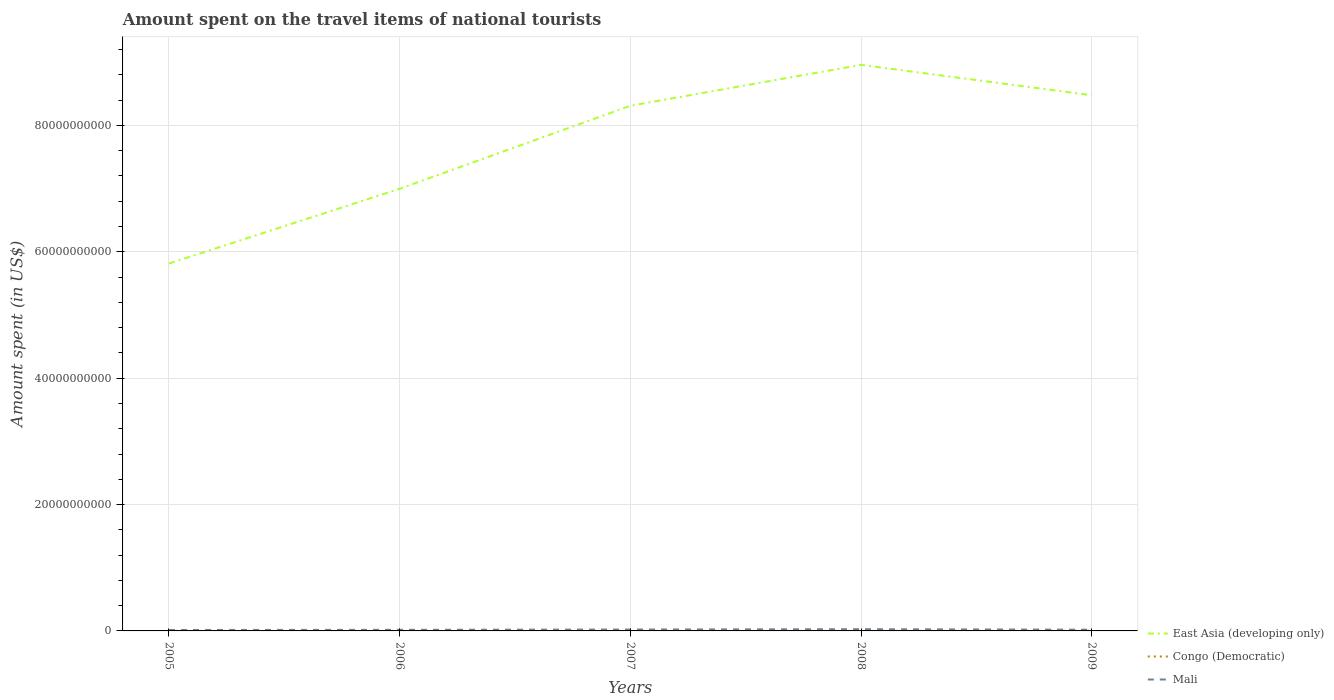In which year was the amount spent on the travel items of national tourists in Mali maximum?
Ensure brevity in your answer.  2005. What is the total amount spent on the travel items of national tourists in Mali in the graph?
Make the answer very short. 2.90e+07. What is the difference between the highest and the second highest amount spent on the travel items of national tourists in Mali?
Your response must be concise. 1.27e+08. What is the difference between the highest and the lowest amount spent on the travel items of national tourists in Mali?
Give a very brief answer. 2. Is the amount spent on the travel items of national tourists in Congo (Democratic) strictly greater than the amount spent on the travel items of national tourists in East Asia (developing only) over the years?
Offer a very short reply. Yes. How many years are there in the graph?
Give a very brief answer. 5. What is the difference between two consecutive major ticks on the Y-axis?
Make the answer very short. 2.00e+1. Does the graph contain grids?
Offer a terse response. Yes. Where does the legend appear in the graph?
Your response must be concise. Bottom right. How many legend labels are there?
Offer a very short reply. 3. What is the title of the graph?
Your answer should be compact. Amount spent on the travel items of national tourists. Does "San Marino" appear as one of the legend labels in the graph?
Your answer should be very brief. No. What is the label or title of the Y-axis?
Offer a very short reply. Amount spent (in US$). What is the Amount spent (in US$) in East Asia (developing only) in 2005?
Provide a succinct answer. 5.81e+1. What is the Amount spent (in US$) of Congo (Democratic) in 2005?
Provide a short and direct response. 3.20e+06. What is the Amount spent (in US$) in Mali in 2005?
Keep it short and to the point. 1.48e+08. What is the Amount spent (in US$) in East Asia (developing only) in 2006?
Provide a short and direct response. 7.00e+1. What is the Amount spent (in US$) in Congo (Democratic) in 2006?
Your answer should be compact. 3.10e+06. What is the Amount spent (in US$) in Mali in 2006?
Offer a terse response. 1.75e+08. What is the Amount spent (in US$) in East Asia (developing only) in 2007?
Make the answer very short. 8.31e+1. What is the Amount spent (in US$) of Mali in 2007?
Ensure brevity in your answer.  2.21e+08. What is the Amount spent (in US$) in East Asia (developing only) in 2008?
Provide a succinct answer. 8.96e+1. What is the Amount spent (in US$) in Mali in 2008?
Provide a short and direct response. 2.75e+08. What is the Amount spent (in US$) in East Asia (developing only) in 2009?
Your answer should be compact. 8.48e+1. What is the Amount spent (in US$) of Congo (Democratic) in 2009?
Ensure brevity in your answer.  2.40e+07. What is the Amount spent (in US$) in Mali in 2009?
Your answer should be very brief. 1.92e+08. Across all years, what is the maximum Amount spent (in US$) in East Asia (developing only)?
Offer a terse response. 8.96e+1. Across all years, what is the maximum Amount spent (in US$) in Congo (Democratic)?
Offer a terse response. 2.40e+07. Across all years, what is the maximum Amount spent (in US$) of Mali?
Keep it short and to the point. 2.75e+08. Across all years, what is the minimum Amount spent (in US$) of East Asia (developing only)?
Keep it short and to the point. 5.81e+1. Across all years, what is the minimum Amount spent (in US$) of Mali?
Ensure brevity in your answer.  1.48e+08. What is the total Amount spent (in US$) in East Asia (developing only) in the graph?
Give a very brief answer. 3.86e+11. What is the total Amount spent (in US$) in Congo (Democratic) in the graph?
Your answer should be compact. 3.17e+07. What is the total Amount spent (in US$) in Mali in the graph?
Your answer should be compact. 1.01e+09. What is the difference between the Amount spent (in US$) in East Asia (developing only) in 2005 and that in 2006?
Ensure brevity in your answer.  -1.18e+1. What is the difference between the Amount spent (in US$) of Congo (Democratic) in 2005 and that in 2006?
Make the answer very short. 1.00e+05. What is the difference between the Amount spent (in US$) of Mali in 2005 and that in 2006?
Offer a terse response. -2.70e+07. What is the difference between the Amount spent (in US$) of East Asia (developing only) in 2005 and that in 2007?
Offer a terse response. -2.50e+1. What is the difference between the Amount spent (in US$) in Congo (Democratic) in 2005 and that in 2007?
Make the answer very short. 2.50e+06. What is the difference between the Amount spent (in US$) of Mali in 2005 and that in 2007?
Provide a succinct answer. -7.30e+07. What is the difference between the Amount spent (in US$) in East Asia (developing only) in 2005 and that in 2008?
Keep it short and to the point. -3.14e+1. What is the difference between the Amount spent (in US$) of Congo (Democratic) in 2005 and that in 2008?
Your answer should be very brief. 2.50e+06. What is the difference between the Amount spent (in US$) in Mali in 2005 and that in 2008?
Ensure brevity in your answer.  -1.27e+08. What is the difference between the Amount spent (in US$) of East Asia (developing only) in 2005 and that in 2009?
Provide a short and direct response. -2.66e+1. What is the difference between the Amount spent (in US$) in Congo (Democratic) in 2005 and that in 2009?
Keep it short and to the point. -2.08e+07. What is the difference between the Amount spent (in US$) in Mali in 2005 and that in 2009?
Your response must be concise. -4.40e+07. What is the difference between the Amount spent (in US$) of East Asia (developing only) in 2006 and that in 2007?
Your response must be concise. -1.31e+1. What is the difference between the Amount spent (in US$) in Congo (Democratic) in 2006 and that in 2007?
Ensure brevity in your answer.  2.40e+06. What is the difference between the Amount spent (in US$) in Mali in 2006 and that in 2007?
Your answer should be compact. -4.60e+07. What is the difference between the Amount spent (in US$) of East Asia (developing only) in 2006 and that in 2008?
Keep it short and to the point. -1.96e+1. What is the difference between the Amount spent (in US$) of Congo (Democratic) in 2006 and that in 2008?
Your answer should be very brief. 2.40e+06. What is the difference between the Amount spent (in US$) in Mali in 2006 and that in 2008?
Keep it short and to the point. -1.00e+08. What is the difference between the Amount spent (in US$) of East Asia (developing only) in 2006 and that in 2009?
Offer a very short reply. -1.48e+1. What is the difference between the Amount spent (in US$) of Congo (Democratic) in 2006 and that in 2009?
Offer a very short reply. -2.09e+07. What is the difference between the Amount spent (in US$) in Mali in 2006 and that in 2009?
Provide a short and direct response. -1.70e+07. What is the difference between the Amount spent (in US$) of East Asia (developing only) in 2007 and that in 2008?
Ensure brevity in your answer.  -6.47e+09. What is the difference between the Amount spent (in US$) of Mali in 2007 and that in 2008?
Your answer should be compact. -5.40e+07. What is the difference between the Amount spent (in US$) in East Asia (developing only) in 2007 and that in 2009?
Provide a short and direct response. -1.67e+09. What is the difference between the Amount spent (in US$) in Congo (Democratic) in 2007 and that in 2009?
Your answer should be compact. -2.33e+07. What is the difference between the Amount spent (in US$) of Mali in 2007 and that in 2009?
Your response must be concise. 2.90e+07. What is the difference between the Amount spent (in US$) in East Asia (developing only) in 2008 and that in 2009?
Provide a short and direct response. 4.81e+09. What is the difference between the Amount spent (in US$) of Congo (Democratic) in 2008 and that in 2009?
Provide a short and direct response. -2.33e+07. What is the difference between the Amount spent (in US$) of Mali in 2008 and that in 2009?
Your answer should be very brief. 8.30e+07. What is the difference between the Amount spent (in US$) in East Asia (developing only) in 2005 and the Amount spent (in US$) in Congo (Democratic) in 2006?
Your response must be concise. 5.81e+1. What is the difference between the Amount spent (in US$) in East Asia (developing only) in 2005 and the Amount spent (in US$) in Mali in 2006?
Offer a terse response. 5.80e+1. What is the difference between the Amount spent (in US$) in Congo (Democratic) in 2005 and the Amount spent (in US$) in Mali in 2006?
Provide a short and direct response. -1.72e+08. What is the difference between the Amount spent (in US$) in East Asia (developing only) in 2005 and the Amount spent (in US$) in Congo (Democratic) in 2007?
Provide a short and direct response. 5.81e+1. What is the difference between the Amount spent (in US$) of East Asia (developing only) in 2005 and the Amount spent (in US$) of Mali in 2007?
Give a very brief answer. 5.79e+1. What is the difference between the Amount spent (in US$) of Congo (Democratic) in 2005 and the Amount spent (in US$) of Mali in 2007?
Offer a very short reply. -2.18e+08. What is the difference between the Amount spent (in US$) in East Asia (developing only) in 2005 and the Amount spent (in US$) in Congo (Democratic) in 2008?
Ensure brevity in your answer.  5.81e+1. What is the difference between the Amount spent (in US$) in East Asia (developing only) in 2005 and the Amount spent (in US$) in Mali in 2008?
Provide a short and direct response. 5.79e+1. What is the difference between the Amount spent (in US$) of Congo (Democratic) in 2005 and the Amount spent (in US$) of Mali in 2008?
Your answer should be compact. -2.72e+08. What is the difference between the Amount spent (in US$) in East Asia (developing only) in 2005 and the Amount spent (in US$) in Congo (Democratic) in 2009?
Offer a very short reply. 5.81e+1. What is the difference between the Amount spent (in US$) of East Asia (developing only) in 2005 and the Amount spent (in US$) of Mali in 2009?
Ensure brevity in your answer.  5.80e+1. What is the difference between the Amount spent (in US$) of Congo (Democratic) in 2005 and the Amount spent (in US$) of Mali in 2009?
Provide a succinct answer. -1.89e+08. What is the difference between the Amount spent (in US$) in East Asia (developing only) in 2006 and the Amount spent (in US$) in Congo (Democratic) in 2007?
Provide a succinct answer. 7.00e+1. What is the difference between the Amount spent (in US$) in East Asia (developing only) in 2006 and the Amount spent (in US$) in Mali in 2007?
Offer a terse response. 6.98e+1. What is the difference between the Amount spent (in US$) of Congo (Democratic) in 2006 and the Amount spent (in US$) of Mali in 2007?
Your answer should be very brief. -2.18e+08. What is the difference between the Amount spent (in US$) in East Asia (developing only) in 2006 and the Amount spent (in US$) in Congo (Democratic) in 2008?
Ensure brevity in your answer.  7.00e+1. What is the difference between the Amount spent (in US$) of East Asia (developing only) in 2006 and the Amount spent (in US$) of Mali in 2008?
Keep it short and to the point. 6.97e+1. What is the difference between the Amount spent (in US$) in Congo (Democratic) in 2006 and the Amount spent (in US$) in Mali in 2008?
Your answer should be compact. -2.72e+08. What is the difference between the Amount spent (in US$) of East Asia (developing only) in 2006 and the Amount spent (in US$) of Congo (Democratic) in 2009?
Provide a short and direct response. 7.00e+1. What is the difference between the Amount spent (in US$) in East Asia (developing only) in 2006 and the Amount spent (in US$) in Mali in 2009?
Your answer should be very brief. 6.98e+1. What is the difference between the Amount spent (in US$) in Congo (Democratic) in 2006 and the Amount spent (in US$) in Mali in 2009?
Your response must be concise. -1.89e+08. What is the difference between the Amount spent (in US$) of East Asia (developing only) in 2007 and the Amount spent (in US$) of Congo (Democratic) in 2008?
Offer a terse response. 8.31e+1. What is the difference between the Amount spent (in US$) in East Asia (developing only) in 2007 and the Amount spent (in US$) in Mali in 2008?
Ensure brevity in your answer.  8.28e+1. What is the difference between the Amount spent (in US$) in Congo (Democratic) in 2007 and the Amount spent (in US$) in Mali in 2008?
Offer a terse response. -2.74e+08. What is the difference between the Amount spent (in US$) in East Asia (developing only) in 2007 and the Amount spent (in US$) in Congo (Democratic) in 2009?
Offer a terse response. 8.31e+1. What is the difference between the Amount spent (in US$) in East Asia (developing only) in 2007 and the Amount spent (in US$) in Mali in 2009?
Provide a succinct answer. 8.29e+1. What is the difference between the Amount spent (in US$) in Congo (Democratic) in 2007 and the Amount spent (in US$) in Mali in 2009?
Offer a terse response. -1.91e+08. What is the difference between the Amount spent (in US$) in East Asia (developing only) in 2008 and the Amount spent (in US$) in Congo (Democratic) in 2009?
Ensure brevity in your answer.  8.96e+1. What is the difference between the Amount spent (in US$) of East Asia (developing only) in 2008 and the Amount spent (in US$) of Mali in 2009?
Your answer should be compact. 8.94e+1. What is the difference between the Amount spent (in US$) in Congo (Democratic) in 2008 and the Amount spent (in US$) in Mali in 2009?
Offer a terse response. -1.91e+08. What is the average Amount spent (in US$) in East Asia (developing only) per year?
Offer a very short reply. 7.71e+1. What is the average Amount spent (in US$) of Congo (Democratic) per year?
Ensure brevity in your answer.  6.34e+06. What is the average Amount spent (in US$) in Mali per year?
Make the answer very short. 2.02e+08. In the year 2005, what is the difference between the Amount spent (in US$) of East Asia (developing only) and Amount spent (in US$) of Congo (Democratic)?
Your answer should be compact. 5.81e+1. In the year 2005, what is the difference between the Amount spent (in US$) of East Asia (developing only) and Amount spent (in US$) of Mali?
Your response must be concise. 5.80e+1. In the year 2005, what is the difference between the Amount spent (in US$) in Congo (Democratic) and Amount spent (in US$) in Mali?
Provide a succinct answer. -1.45e+08. In the year 2006, what is the difference between the Amount spent (in US$) of East Asia (developing only) and Amount spent (in US$) of Congo (Democratic)?
Make the answer very short. 7.00e+1. In the year 2006, what is the difference between the Amount spent (in US$) of East Asia (developing only) and Amount spent (in US$) of Mali?
Your answer should be very brief. 6.98e+1. In the year 2006, what is the difference between the Amount spent (in US$) in Congo (Democratic) and Amount spent (in US$) in Mali?
Provide a short and direct response. -1.72e+08. In the year 2007, what is the difference between the Amount spent (in US$) in East Asia (developing only) and Amount spent (in US$) in Congo (Democratic)?
Offer a very short reply. 8.31e+1. In the year 2007, what is the difference between the Amount spent (in US$) of East Asia (developing only) and Amount spent (in US$) of Mali?
Give a very brief answer. 8.29e+1. In the year 2007, what is the difference between the Amount spent (in US$) of Congo (Democratic) and Amount spent (in US$) of Mali?
Keep it short and to the point. -2.20e+08. In the year 2008, what is the difference between the Amount spent (in US$) of East Asia (developing only) and Amount spent (in US$) of Congo (Democratic)?
Your answer should be compact. 8.96e+1. In the year 2008, what is the difference between the Amount spent (in US$) in East Asia (developing only) and Amount spent (in US$) in Mali?
Keep it short and to the point. 8.93e+1. In the year 2008, what is the difference between the Amount spent (in US$) of Congo (Democratic) and Amount spent (in US$) of Mali?
Offer a very short reply. -2.74e+08. In the year 2009, what is the difference between the Amount spent (in US$) of East Asia (developing only) and Amount spent (in US$) of Congo (Democratic)?
Make the answer very short. 8.48e+1. In the year 2009, what is the difference between the Amount spent (in US$) of East Asia (developing only) and Amount spent (in US$) of Mali?
Your answer should be very brief. 8.46e+1. In the year 2009, what is the difference between the Amount spent (in US$) of Congo (Democratic) and Amount spent (in US$) of Mali?
Your answer should be very brief. -1.68e+08. What is the ratio of the Amount spent (in US$) of East Asia (developing only) in 2005 to that in 2006?
Offer a terse response. 0.83. What is the ratio of the Amount spent (in US$) in Congo (Democratic) in 2005 to that in 2006?
Provide a short and direct response. 1.03. What is the ratio of the Amount spent (in US$) in Mali in 2005 to that in 2006?
Ensure brevity in your answer.  0.85. What is the ratio of the Amount spent (in US$) in East Asia (developing only) in 2005 to that in 2007?
Offer a terse response. 0.7. What is the ratio of the Amount spent (in US$) of Congo (Democratic) in 2005 to that in 2007?
Provide a succinct answer. 4.57. What is the ratio of the Amount spent (in US$) in Mali in 2005 to that in 2007?
Ensure brevity in your answer.  0.67. What is the ratio of the Amount spent (in US$) of East Asia (developing only) in 2005 to that in 2008?
Offer a very short reply. 0.65. What is the ratio of the Amount spent (in US$) in Congo (Democratic) in 2005 to that in 2008?
Your response must be concise. 4.57. What is the ratio of the Amount spent (in US$) of Mali in 2005 to that in 2008?
Give a very brief answer. 0.54. What is the ratio of the Amount spent (in US$) of East Asia (developing only) in 2005 to that in 2009?
Provide a succinct answer. 0.69. What is the ratio of the Amount spent (in US$) of Congo (Democratic) in 2005 to that in 2009?
Ensure brevity in your answer.  0.13. What is the ratio of the Amount spent (in US$) in Mali in 2005 to that in 2009?
Offer a terse response. 0.77. What is the ratio of the Amount spent (in US$) of East Asia (developing only) in 2006 to that in 2007?
Give a very brief answer. 0.84. What is the ratio of the Amount spent (in US$) of Congo (Democratic) in 2006 to that in 2007?
Offer a very short reply. 4.43. What is the ratio of the Amount spent (in US$) in Mali in 2006 to that in 2007?
Keep it short and to the point. 0.79. What is the ratio of the Amount spent (in US$) of East Asia (developing only) in 2006 to that in 2008?
Make the answer very short. 0.78. What is the ratio of the Amount spent (in US$) of Congo (Democratic) in 2006 to that in 2008?
Offer a very short reply. 4.43. What is the ratio of the Amount spent (in US$) of Mali in 2006 to that in 2008?
Give a very brief answer. 0.64. What is the ratio of the Amount spent (in US$) in East Asia (developing only) in 2006 to that in 2009?
Keep it short and to the point. 0.83. What is the ratio of the Amount spent (in US$) in Congo (Democratic) in 2006 to that in 2009?
Give a very brief answer. 0.13. What is the ratio of the Amount spent (in US$) of Mali in 2006 to that in 2009?
Provide a succinct answer. 0.91. What is the ratio of the Amount spent (in US$) of East Asia (developing only) in 2007 to that in 2008?
Provide a succinct answer. 0.93. What is the ratio of the Amount spent (in US$) in Congo (Democratic) in 2007 to that in 2008?
Provide a succinct answer. 1. What is the ratio of the Amount spent (in US$) of Mali in 2007 to that in 2008?
Give a very brief answer. 0.8. What is the ratio of the Amount spent (in US$) of East Asia (developing only) in 2007 to that in 2009?
Offer a very short reply. 0.98. What is the ratio of the Amount spent (in US$) of Congo (Democratic) in 2007 to that in 2009?
Your response must be concise. 0.03. What is the ratio of the Amount spent (in US$) in Mali in 2007 to that in 2009?
Your response must be concise. 1.15. What is the ratio of the Amount spent (in US$) in East Asia (developing only) in 2008 to that in 2009?
Offer a very short reply. 1.06. What is the ratio of the Amount spent (in US$) of Congo (Democratic) in 2008 to that in 2009?
Ensure brevity in your answer.  0.03. What is the ratio of the Amount spent (in US$) of Mali in 2008 to that in 2009?
Offer a very short reply. 1.43. What is the difference between the highest and the second highest Amount spent (in US$) in East Asia (developing only)?
Make the answer very short. 4.81e+09. What is the difference between the highest and the second highest Amount spent (in US$) of Congo (Democratic)?
Give a very brief answer. 2.08e+07. What is the difference between the highest and the second highest Amount spent (in US$) of Mali?
Make the answer very short. 5.40e+07. What is the difference between the highest and the lowest Amount spent (in US$) in East Asia (developing only)?
Offer a terse response. 3.14e+1. What is the difference between the highest and the lowest Amount spent (in US$) of Congo (Democratic)?
Your answer should be compact. 2.33e+07. What is the difference between the highest and the lowest Amount spent (in US$) in Mali?
Offer a terse response. 1.27e+08. 